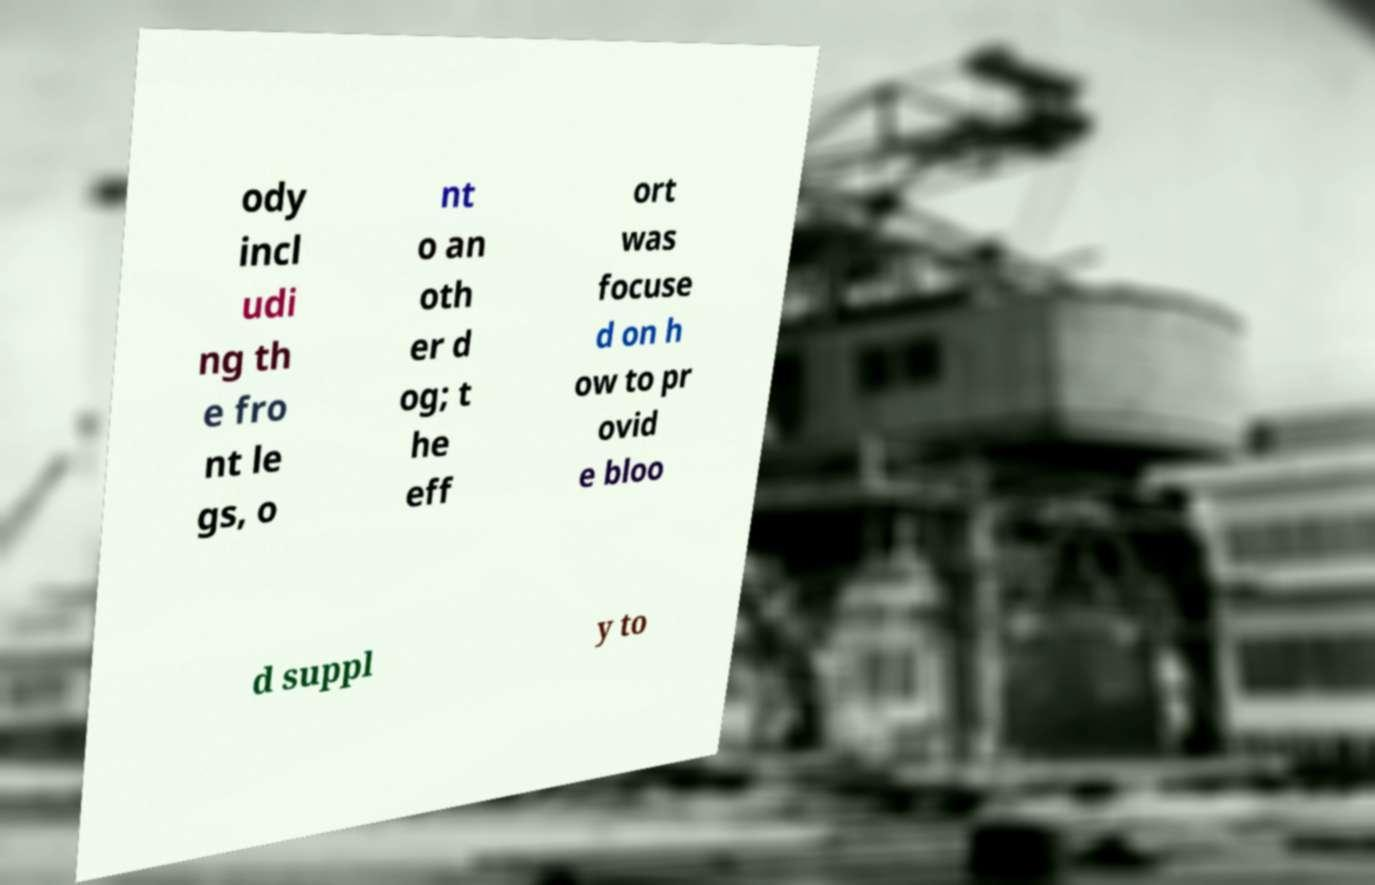What messages or text are displayed in this image? I need them in a readable, typed format. ody incl udi ng th e fro nt le gs, o nt o an oth er d og; t he eff ort was focuse d on h ow to pr ovid e bloo d suppl y to 